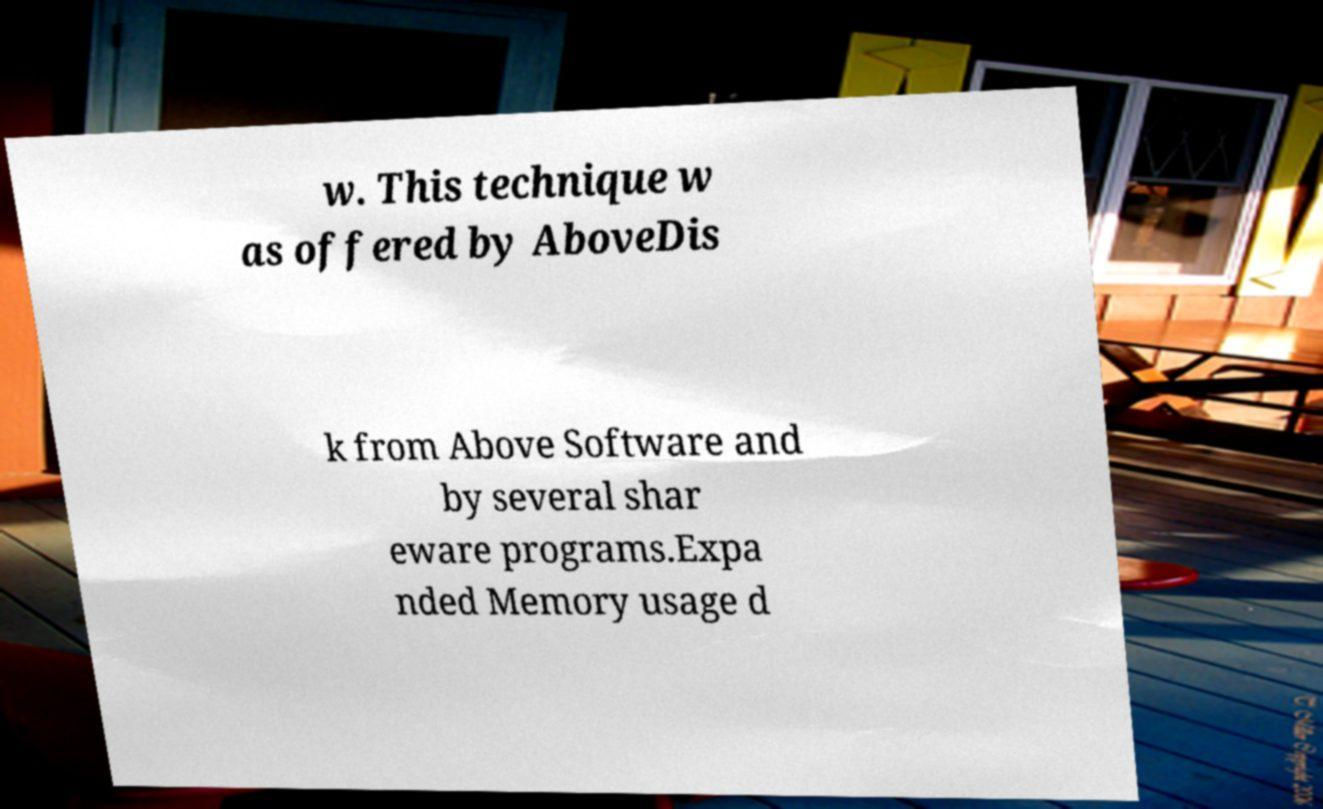Please identify and transcribe the text found in this image. w. This technique w as offered by AboveDis k from Above Software and by several shar eware programs.Expa nded Memory usage d 